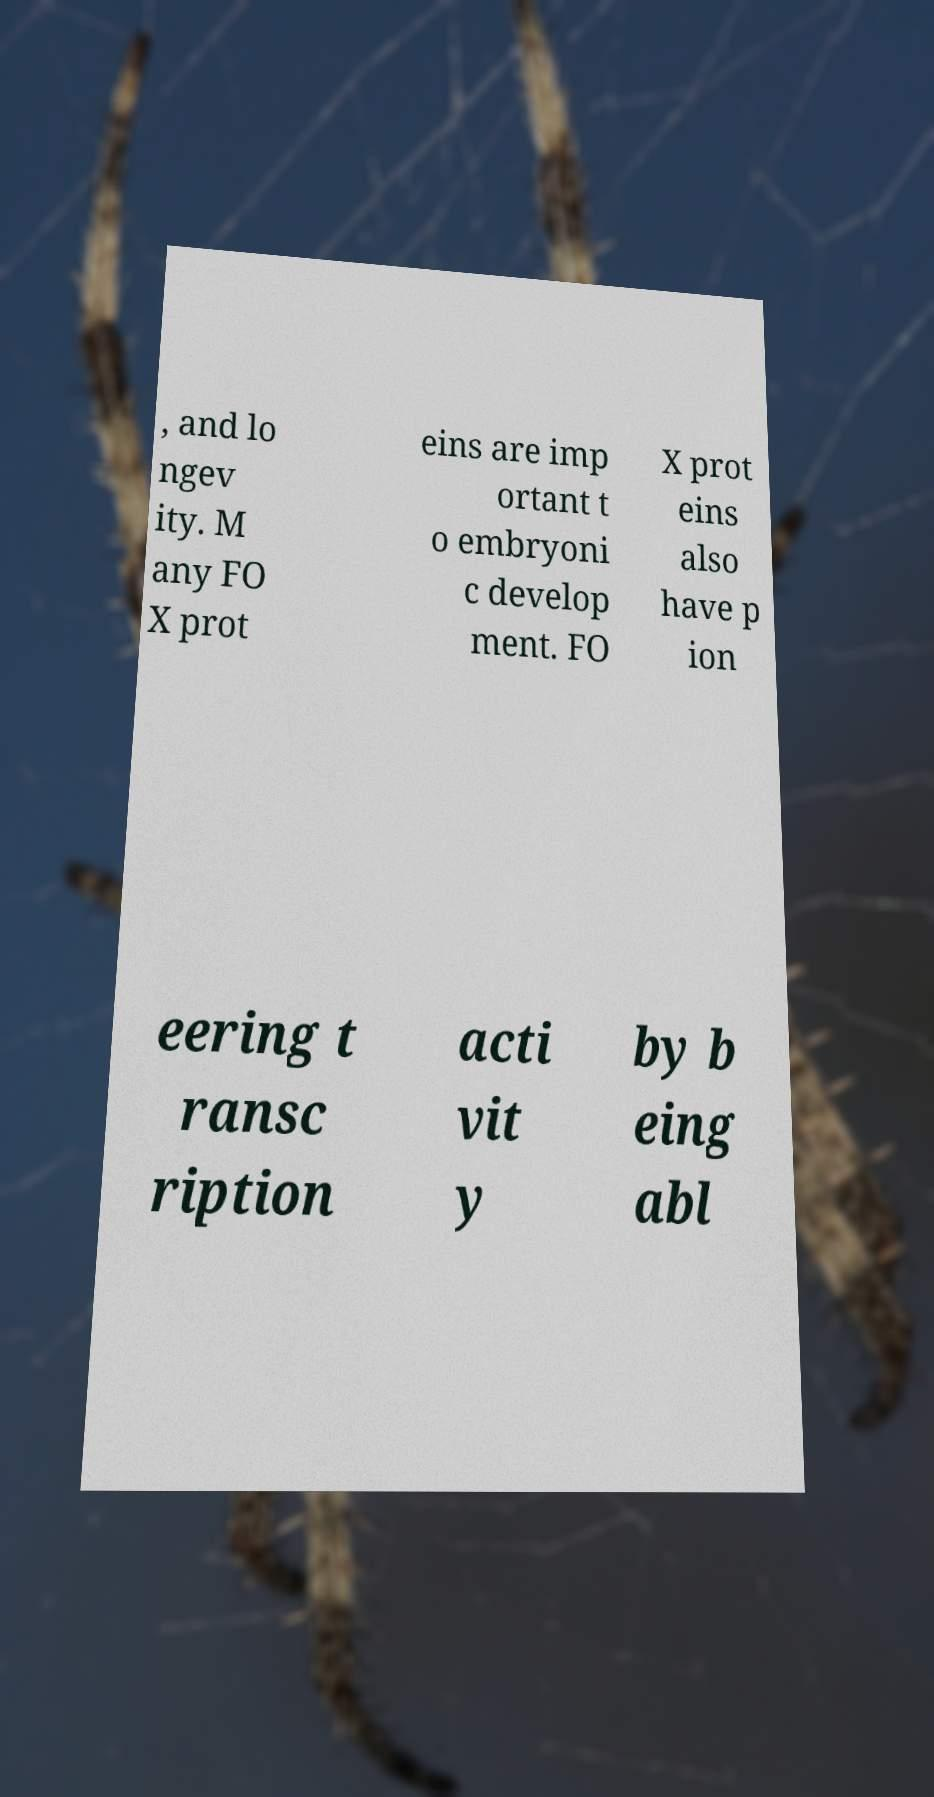Please identify and transcribe the text found in this image. , and lo ngev ity. M any FO X prot eins are imp ortant t o embryoni c develop ment. FO X prot eins also have p ion eering t ransc ription acti vit y by b eing abl 